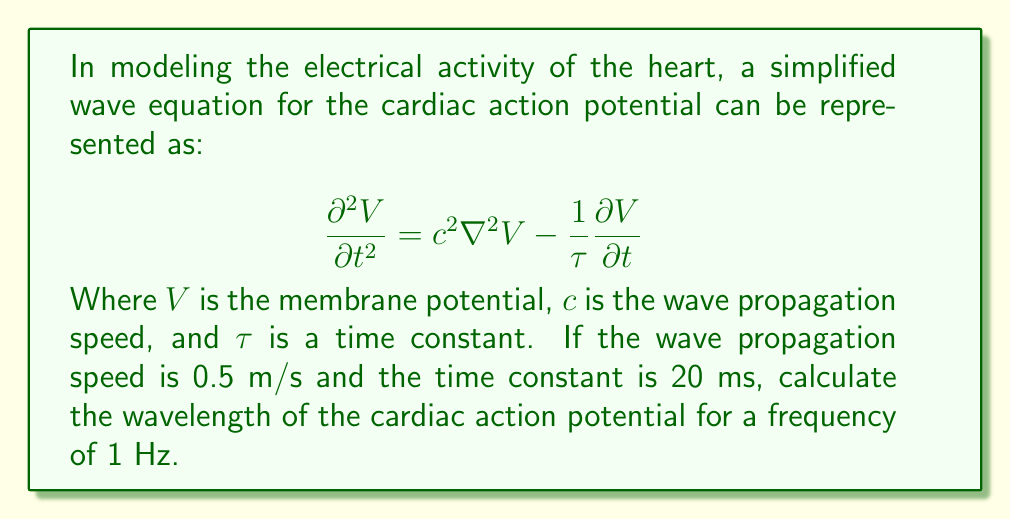What is the answer to this math problem? Let's approach this step-by-step:

1) The general form of a wave equation is:
   $$\frac{\partial^2 V}{\partial t^2} = c^2 \nabla^2 V$$

2) Our equation has an additional term $-\frac{1}{\tau} \frac{\partial V}{\partial t}$, which represents damping. However, for wavelength calculations, we can focus on the wave-like part.

3) For a wave, the relationship between wavelength ($\lambda$), frequency ($f$), and wave speed ($c$) is:
   $$c = f\lambda$$

4) We are given:
   $c = 0.5$ m/s
   $f = 1$ Hz

5) Rearranging the equation to solve for $\lambda$:
   $$\lambda = \frac{c}{f}$$

6) Substituting the values:
   $$\lambda = \frac{0.5 \text{ m/s}}{1 \text{ Hz}} = 0.5 \text{ m}$$

Therefore, the wavelength of the cardiac action potential under these conditions is 0.5 meters.
Answer: 0.5 m 